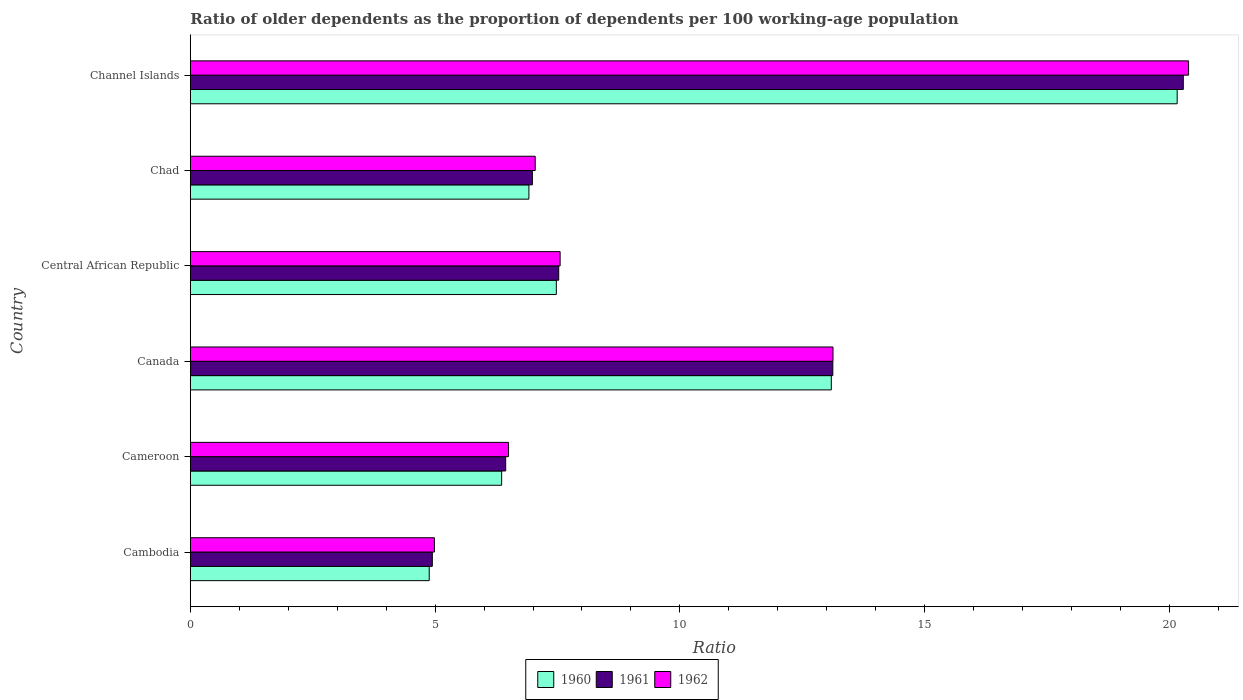Are the number of bars per tick equal to the number of legend labels?
Offer a terse response. Yes. Are the number of bars on each tick of the Y-axis equal?
Your answer should be very brief. Yes. How many bars are there on the 1st tick from the top?
Ensure brevity in your answer.  3. What is the label of the 5th group of bars from the top?
Your response must be concise. Cameroon. What is the age dependency ratio(old) in 1961 in Cameroon?
Offer a terse response. 6.44. Across all countries, what is the maximum age dependency ratio(old) in 1962?
Give a very brief answer. 20.39. Across all countries, what is the minimum age dependency ratio(old) in 1961?
Provide a short and direct response. 4.94. In which country was the age dependency ratio(old) in 1961 maximum?
Provide a short and direct response. Channel Islands. In which country was the age dependency ratio(old) in 1961 minimum?
Offer a very short reply. Cambodia. What is the total age dependency ratio(old) in 1962 in the graph?
Provide a short and direct response. 59.6. What is the difference between the age dependency ratio(old) in 1960 in Canada and that in Chad?
Offer a very short reply. 6.18. What is the difference between the age dependency ratio(old) in 1961 in Cameroon and the age dependency ratio(old) in 1962 in Channel Islands?
Your answer should be very brief. -13.95. What is the average age dependency ratio(old) in 1961 per country?
Give a very brief answer. 9.88. What is the difference between the age dependency ratio(old) in 1960 and age dependency ratio(old) in 1961 in Cambodia?
Your response must be concise. -0.06. In how many countries, is the age dependency ratio(old) in 1961 greater than 16 ?
Your answer should be compact. 1. What is the ratio of the age dependency ratio(old) in 1962 in Cameroon to that in Canada?
Give a very brief answer. 0.5. Is the age dependency ratio(old) in 1961 in Cameroon less than that in Channel Islands?
Provide a succinct answer. Yes. What is the difference between the highest and the second highest age dependency ratio(old) in 1962?
Give a very brief answer. 7.26. What is the difference between the highest and the lowest age dependency ratio(old) in 1960?
Your answer should be compact. 15.28. In how many countries, is the age dependency ratio(old) in 1961 greater than the average age dependency ratio(old) in 1961 taken over all countries?
Your answer should be very brief. 2. Is the sum of the age dependency ratio(old) in 1961 in Chad and Channel Islands greater than the maximum age dependency ratio(old) in 1960 across all countries?
Offer a terse response. Yes. What does the 2nd bar from the top in Chad represents?
Offer a terse response. 1961. Is it the case that in every country, the sum of the age dependency ratio(old) in 1961 and age dependency ratio(old) in 1962 is greater than the age dependency ratio(old) in 1960?
Ensure brevity in your answer.  Yes. Are all the bars in the graph horizontal?
Make the answer very short. Yes. Does the graph contain grids?
Ensure brevity in your answer.  No. Where does the legend appear in the graph?
Offer a very short reply. Bottom center. How many legend labels are there?
Offer a terse response. 3. How are the legend labels stacked?
Provide a short and direct response. Horizontal. What is the title of the graph?
Keep it short and to the point. Ratio of older dependents as the proportion of dependents per 100 working-age population. Does "1999" appear as one of the legend labels in the graph?
Offer a terse response. No. What is the label or title of the X-axis?
Offer a terse response. Ratio. What is the label or title of the Y-axis?
Ensure brevity in your answer.  Country. What is the Ratio of 1960 in Cambodia?
Your answer should be compact. 4.88. What is the Ratio of 1961 in Cambodia?
Keep it short and to the point. 4.94. What is the Ratio in 1962 in Cambodia?
Offer a terse response. 4.99. What is the Ratio of 1960 in Cameroon?
Your response must be concise. 6.36. What is the Ratio of 1961 in Cameroon?
Offer a terse response. 6.44. What is the Ratio of 1962 in Cameroon?
Give a very brief answer. 6.5. What is the Ratio of 1960 in Canada?
Offer a terse response. 13.09. What is the Ratio of 1961 in Canada?
Give a very brief answer. 13.12. What is the Ratio in 1962 in Canada?
Offer a very short reply. 13.13. What is the Ratio of 1960 in Central African Republic?
Keep it short and to the point. 7.48. What is the Ratio of 1961 in Central African Republic?
Provide a short and direct response. 7.53. What is the Ratio of 1962 in Central African Republic?
Make the answer very short. 7.55. What is the Ratio in 1960 in Chad?
Offer a terse response. 6.92. What is the Ratio of 1961 in Chad?
Provide a succinct answer. 6.99. What is the Ratio in 1962 in Chad?
Offer a very short reply. 7.05. What is the Ratio of 1960 in Channel Islands?
Your answer should be very brief. 20.16. What is the Ratio in 1961 in Channel Islands?
Your answer should be compact. 20.28. What is the Ratio of 1962 in Channel Islands?
Provide a succinct answer. 20.39. Across all countries, what is the maximum Ratio in 1960?
Your response must be concise. 20.16. Across all countries, what is the maximum Ratio in 1961?
Give a very brief answer. 20.28. Across all countries, what is the maximum Ratio of 1962?
Your answer should be very brief. 20.39. Across all countries, what is the minimum Ratio in 1960?
Keep it short and to the point. 4.88. Across all countries, what is the minimum Ratio of 1961?
Your response must be concise. 4.94. Across all countries, what is the minimum Ratio in 1962?
Your answer should be compact. 4.99. What is the total Ratio of 1960 in the graph?
Your answer should be compact. 58.88. What is the total Ratio of 1961 in the graph?
Ensure brevity in your answer.  59.3. What is the total Ratio of 1962 in the graph?
Provide a short and direct response. 59.6. What is the difference between the Ratio of 1960 in Cambodia and that in Cameroon?
Your answer should be very brief. -1.48. What is the difference between the Ratio in 1961 in Cambodia and that in Cameroon?
Offer a terse response. -1.5. What is the difference between the Ratio in 1962 in Cambodia and that in Cameroon?
Ensure brevity in your answer.  -1.51. What is the difference between the Ratio of 1960 in Cambodia and that in Canada?
Ensure brevity in your answer.  -8.21. What is the difference between the Ratio in 1961 in Cambodia and that in Canada?
Make the answer very short. -8.18. What is the difference between the Ratio of 1962 in Cambodia and that in Canada?
Ensure brevity in your answer.  -8.14. What is the difference between the Ratio in 1960 in Cambodia and that in Central African Republic?
Your answer should be very brief. -2.6. What is the difference between the Ratio in 1961 in Cambodia and that in Central African Republic?
Your response must be concise. -2.58. What is the difference between the Ratio in 1962 in Cambodia and that in Central African Republic?
Provide a short and direct response. -2.57. What is the difference between the Ratio of 1960 in Cambodia and that in Chad?
Your response must be concise. -2.04. What is the difference between the Ratio of 1961 in Cambodia and that in Chad?
Give a very brief answer. -2.04. What is the difference between the Ratio of 1962 in Cambodia and that in Chad?
Give a very brief answer. -2.06. What is the difference between the Ratio of 1960 in Cambodia and that in Channel Islands?
Offer a terse response. -15.28. What is the difference between the Ratio in 1961 in Cambodia and that in Channel Islands?
Your response must be concise. -15.34. What is the difference between the Ratio of 1962 in Cambodia and that in Channel Islands?
Your answer should be very brief. -15.4. What is the difference between the Ratio in 1960 in Cameroon and that in Canada?
Keep it short and to the point. -6.73. What is the difference between the Ratio in 1961 in Cameroon and that in Canada?
Your answer should be compact. -6.68. What is the difference between the Ratio of 1962 in Cameroon and that in Canada?
Ensure brevity in your answer.  -6.63. What is the difference between the Ratio of 1960 in Cameroon and that in Central African Republic?
Give a very brief answer. -1.12. What is the difference between the Ratio in 1961 in Cameroon and that in Central African Republic?
Your response must be concise. -1.08. What is the difference between the Ratio of 1962 in Cameroon and that in Central African Republic?
Your answer should be very brief. -1.05. What is the difference between the Ratio in 1960 in Cameroon and that in Chad?
Give a very brief answer. -0.56. What is the difference between the Ratio in 1961 in Cameroon and that in Chad?
Provide a short and direct response. -0.55. What is the difference between the Ratio of 1962 in Cameroon and that in Chad?
Provide a short and direct response. -0.54. What is the difference between the Ratio in 1960 in Cameroon and that in Channel Islands?
Your response must be concise. -13.8. What is the difference between the Ratio of 1961 in Cameroon and that in Channel Islands?
Ensure brevity in your answer.  -13.84. What is the difference between the Ratio of 1962 in Cameroon and that in Channel Islands?
Your answer should be compact. -13.89. What is the difference between the Ratio in 1960 in Canada and that in Central African Republic?
Your answer should be very brief. 5.62. What is the difference between the Ratio in 1961 in Canada and that in Central African Republic?
Offer a terse response. 5.6. What is the difference between the Ratio of 1962 in Canada and that in Central African Republic?
Make the answer very short. 5.57. What is the difference between the Ratio in 1960 in Canada and that in Chad?
Ensure brevity in your answer.  6.18. What is the difference between the Ratio of 1961 in Canada and that in Chad?
Your response must be concise. 6.14. What is the difference between the Ratio of 1962 in Canada and that in Chad?
Provide a short and direct response. 6.08. What is the difference between the Ratio of 1960 in Canada and that in Channel Islands?
Provide a succinct answer. -7.06. What is the difference between the Ratio in 1961 in Canada and that in Channel Islands?
Keep it short and to the point. -7.16. What is the difference between the Ratio in 1962 in Canada and that in Channel Islands?
Ensure brevity in your answer.  -7.26. What is the difference between the Ratio in 1960 in Central African Republic and that in Chad?
Your response must be concise. 0.56. What is the difference between the Ratio of 1961 in Central African Republic and that in Chad?
Offer a terse response. 0.54. What is the difference between the Ratio of 1962 in Central African Republic and that in Chad?
Provide a short and direct response. 0.51. What is the difference between the Ratio of 1960 in Central African Republic and that in Channel Islands?
Provide a succinct answer. -12.68. What is the difference between the Ratio of 1961 in Central African Republic and that in Channel Islands?
Offer a very short reply. -12.76. What is the difference between the Ratio in 1962 in Central African Republic and that in Channel Islands?
Keep it short and to the point. -12.84. What is the difference between the Ratio of 1960 in Chad and that in Channel Islands?
Keep it short and to the point. -13.24. What is the difference between the Ratio in 1961 in Chad and that in Channel Islands?
Your answer should be compact. -13.3. What is the difference between the Ratio in 1962 in Chad and that in Channel Islands?
Offer a very short reply. -13.35. What is the difference between the Ratio in 1960 in Cambodia and the Ratio in 1961 in Cameroon?
Your answer should be compact. -1.56. What is the difference between the Ratio of 1960 in Cambodia and the Ratio of 1962 in Cameroon?
Your answer should be compact. -1.62. What is the difference between the Ratio in 1961 in Cambodia and the Ratio in 1962 in Cameroon?
Your answer should be very brief. -1.56. What is the difference between the Ratio of 1960 in Cambodia and the Ratio of 1961 in Canada?
Your response must be concise. -8.24. What is the difference between the Ratio in 1960 in Cambodia and the Ratio in 1962 in Canada?
Your response must be concise. -8.25. What is the difference between the Ratio in 1961 in Cambodia and the Ratio in 1962 in Canada?
Make the answer very short. -8.18. What is the difference between the Ratio of 1960 in Cambodia and the Ratio of 1961 in Central African Republic?
Keep it short and to the point. -2.65. What is the difference between the Ratio of 1960 in Cambodia and the Ratio of 1962 in Central African Republic?
Provide a short and direct response. -2.67. What is the difference between the Ratio in 1961 in Cambodia and the Ratio in 1962 in Central African Republic?
Provide a succinct answer. -2.61. What is the difference between the Ratio in 1960 in Cambodia and the Ratio in 1961 in Chad?
Provide a succinct answer. -2.11. What is the difference between the Ratio of 1960 in Cambodia and the Ratio of 1962 in Chad?
Provide a short and direct response. -2.17. What is the difference between the Ratio of 1961 in Cambodia and the Ratio of 1962 in Chad?
Your response must be concise. -2.1. What is the difference between the Ratio in 1960 in Cambodia and the Ratio in 1961 in Channel Islands?
Give a very brief answer. -15.4. What is the difference between the Ratio of 1960 in Cambodia and the Ratio of 1962 in Channel Islands?
Make the answer very short. -15.51. What is the difference between the Ratio of 1961 in Cambodia and the Ratio of 1962 in Channel Islands?
Your response must be concise. -15.45. What is the difference between the Ratio in 1960 in Cameroon and the Ratio in 1961 in Canada?
Your answer should be very brief. -6.76. What is the difference between the Ratio in 1960 in Cameroon and the Ratio in 1962 in Canada?
Your answer should be very brief. -6.77. What is the difference between the Ratio of 1961 in Cameroon and the Ratio of 1962 in Canada?
Ensure brevity in your answer.  -6.69. What is the difference between the Ratio of 1960 in Cameroon and the Ratio of 1961 in Central African Republic?
Your answer should be very brief. -1.17. What is the difference between the Ratio of 1960 in Cameroon and the Ratio of 1962 in Central African Republic?
Keep it short and to the point. -1.19. What is the difference between the Ratio of 1961 in Cameroon and the Ratio of 1962 in Central African Republic?
Provide a short and direct response. -1.11. What is the difference between the Ratio in 1960 in Cameroon and the Ratio in 1961 in Chad?
Offer a very short reply. -0.63. What is the difference between the Ratio of 1960 in Cameroon and the Ratio of 1962 in Chad?
Your response must be concise. -0.69. What is the difference between the Ratio in 1961 in Cameroon and the Ratio in 1962 in Chad?
Your answer should be very brief. -0.6. What is the difference between the Ratio in 1960 in Cameroon and the Ratio in 1961 in Channel Islands?
Provide a short and direct response. -13.92. What is the difference between the Ratio in 1960 in Cameroon and the Ratio in 1962 in Channel Islands?
Your answer should be very brief. -14.03. What is the difference between the Ratio in 1961 in Cameroon and the Ratio in 1962 in Channel Islands?
Ensure brevity in your answer.  -13.95. What is the difference between the Ratio of 1960 in Canada and the Ratio of 1961 in Central African Republic?
Provide a short and direct response. 5.57. What is the difference between the Ratio in 1960 in Canada and the Ratio in 1962 in Central African Republic?
Your answer should be compact. 5.54. What is the difference between the Ratio of 1961 in Canada and the Ratio of 1962 in Central African Republic?
Your response must be concise. 5.57. What is the difference between the Ratio in 1960 in Canada and the Ratio in 1961 in Chad?
Make the answer very short. 6.11. What is the difference between the Ratio of 1960 in Canada and the Ratio of 1962 in Chad?
Offer a very short reply. 6.05. What is the difference between the Ratio in 1961 in Canada and the Ratio in 1962 in Chad?
Give a very brief answer. 6.08. What is the difference between the Ratio in 1960 in Canada and the Ratio in 1961 in Channel Islands?
Give a very brief answer. -7.19. What is the difference between the Ratio of 1960 in Canada and the Ratio of 1962 in Channel Islands?
Ensure brevity in your answer.  -7.3. What is the difference between the Ratio of 1961 in Canada and the Ratio of 1962 in Channel Islands?
Give a very brief answer. -7.27. What is the difference between the Ratio of 1960 in Central African Republic and the Ratio of 1961 in Chad?
Provide a succinct answer. 0.49. What is the difference between the Ratio of 1960 in Central African Republic and the Ratio of 1962 in Chad?
Your answer should be compact. 0.43. What is the difference between the Ratio in 1961 in Central African Republic and the Ratio in 1962 in Chad?
Offer a terse response. 0.48. What is the difference between the Ratio of 1960 in Central African Republic and the Ratio of 1961 in Channel Islands?
Your answer should be compact. -12.81. What is the difference between the Ratio of 1960 in Central African Republic and the Ratio of 1962 in Channel Islands?
Make the answer very short. -12.91. What is the difference between the Ratio in 1961 in Central African Republic and the Ratio in 1962 in Channel Islands?
Keep it short and to the point. -12.87. What is the difference between the Ratio of 1960 in Chad and the Ratio of 1961 in Channel Islands?
Provide a succinct answer. -13.37. What is the difference between the Ratio of 1960 in Chad and the Ratio of 1962 in Channel Islands?
Provide a succinct answer. -13.47. What is the difference between the Ratio of 1961 in Chad and the Ratio of 1962 in Channel Islands?
Provide a succinct answer. -13.4. What is the average Ratio in 1960 per country?
Your answer should be compact. 9.81. What is the average Ratio of 1961 per country?
Your answer should be compact. 9.88. What is the average Ratio of 1962 per country?
Your answer should be compact. 9.93. What is the difference between the Ratio in 1960 and Ratio in 1961 in Cambodia?
Your response must be concise. -0.06. What is the difference between the Ratio in 1960 and Ratio in 1962 in Cambodia?
Offer a terse response. -0.11. What is the difference between the Ratio of 1961 and Ratio of 1962 in Cambodia?
Ensure brevity in your answer.  -0.04. What is the difference between the Ratio in 1960 and Ratio in 1961 in Cameroon?
Your answer should be very brief. -0.08. What is the difference between the Ratio in 1960 and Ratio in 1962 in Cameroon?
Provide a short and direct response. -0.14. What is the difference between the Ratio in 1961 and Ratio in 1962 in Cameroon?
Your answer should be compact. -0.06. What is the difference between the Ratio of 1960 and Ratio of 1961 in Canada?
Provide a short and direct response. -0.03. What is the difference between the Ratio in 1960 and Ratio in 1962 in Canada?
Provide a succinct answer. -0.03. What is the difference between the Ratio in 1961 and Ratio in 1962 in Canada?
Your response must be concise. -0. What is the difference between the Ratio of 1960 and Ratio of 1961 in Central African Republic?
Ensure brevity in your answer.  -0.05. What is the difference between the Ratio of 1960 and Ratio of 1962 in Central African Republic?
Offer a very short reply. -0.08. What is the difference between the Ratio of 1961 and Ratio of 1962 in Central African Republic?
Keep it short and to the point. -0.03. What is the difference between the Ratio of 1960 and Ratio of 1961 in Chad?
Your answer should be very brief. -0.07. What is the difference between the Ratio of 1960 and Ratio of 1962 in Chad?
Your answer should be compact. -0.13. What is the difference between the Ratio in 1961 and Ratio in 1962 in Chad?
Make the answer very short. -0.06. What is the difference between the Ratio in 1960 and Ratio in 1961 in Channel Islands?
Provide a succinct answer. -0.12. What is the difference between the Ratio in 1960 and Ratio in 1962 in Channel Islands?
Provide a short and direct response. -0.23. What is the difference between the Ratio of 1961 and Ratio of 1962 in Channel Islands?
Keep it short and to the point. -0.11. What is the ratio of the Ratio of 1960 in Cambodia to that in Cameroon?
Your answer should be compact. 0.77. What is the ratio of the Ratio in 1961 in Cambodia to that in Cameroon?
Offer a very short reply. 0.77. What is the ratio of the Ratio in 1962 in Cambodia to that in Cameroon?
Your response must be concise. 0.77. What is the ratio of the Ratio of 1960 in Cambodia to that in Canada?
Your answer should be very brief. 0.37. What is the ratio of the Ratio in 1961 in Cambodia to that in Canada?
Your answer should be compact. 0.38. What is the ratio of the Ratio of 1962 in Cambodia to that in Canada?
Your answer should be very brief. 0.38. What is the ratio of the Ratio in 1960 in Cambodia to that in Central African Republic?
Offer a very short reply. 0.65. What is the ratio of the Ratio in 1961 in Cambodia to that in Central African Republic?
Your answer should be compact. 0.66. What is the ratio of the Ratio in 1962 in Cambodia to that in Central African Republic?
Keep it short and to the point. 0.66. What is the ratio of the Ratio of 1960 in Cambodia to that in Chad?
Your answer should be compact. 0.71. What is the ratio of the Ratio in 1961 in Cambodia to that in Chad?
Give a very brief answer. 0.71. What is the ratio of the Ratio of 1962 in Cambodia to that in Chad?
Give a very brief answer. 0.71. What is the ratio of the Ratio of 1960 in Cambodia to that in Channel Islands?
Ensure brevity in your answer.  0.24. What is the ratio of the Ratio in 1961 in Cambodia to that in Channel Islands?
Offer a very short reply. 0.24. What is the ratio of the Ratio of 1962 in Cambodia to that in Channel Islands?
Keep it short and to the point. 0.24. What is the ratio of the Ratio of 1960 in Cameroon to that in Canada?
Your answer should be compact. 0.49. What is the ratio of the Ratio of 1961 in Cameroon to that in Canada?
Your answer should be very brief. 0.49. What is the ratio of the Ratio in 1962 in Cameroon to that in Canada?
Your answer should be compact. 0.5. What is the ratio of the Ratio of 1960 in Cameroon to that in Central African Republic?
Your answer should be very brief. 0.85. What is the ratio of the Ratio in 1961 in Cameroon to that in Central African Republic?
Give a very brief answer. 0.86. What is the ratio of the Ratio of 1962 in Cameroon to that in Central African Republic?
Provide a short and direct response. 0.86. What is the ratio of the Ratio of 1960 in Cameroon to that in Chad?
Offer a terse response. 0.92. What is the ratio of the Ratio in 1961 in Cameroon to that in Chad?
Keep it short and to the point. 0.92. What is the ratio of the Ratio in 1962 in Cameroon to that in Chad?
Provide a short and direct response. 0.92. What is the ratio of the Ratio in 1960 in Cameroon to that in Channel Islands?
Keep it short and to the point. 0.32. What is the ratio of the Ratio in 1961 in Cameroon to that in Channel Islands?
Ensure brevity in your answer.  0.32. What is the ratio of the Ratio of 1962 in Cameroon to that in Channel Islands?
Give a very brief answer. 0.32. What is the ratio of the Ratio in 1960 in Canada to that in Central African Republic?
Your response must be concise. 1.75. What is the ratio of the Ratio in 1961 in Canada to that in Central African Republic?
Offer a terse response. 1.74. What is the ratio of the Ratio of 1962 in Canada to that in Central African Republic?
Make the answer very short. 1.74. What is the ratio of the Ratio of 1960 in Canada to that in Chad?
Give a very brief answer. 1.89. What is the ratio of the Ratio in 1961 in Canada to that in Chad?
Your response must be concise. 1.88. What is the ratio of the Ratio in 1962 in Canada to that in Chad?
Ensure brevity in your answer.  1.86. What is the ratio of the Ratio of 1960 in Canada to that in Channel Islands?
Provide a short and direct response. 0.65. What is the ratio of the Ratio of 1961 in Canada to that in Channel Islands?
Give a very brief answer. 0.65. What is the ratio of the Ratio in 1962 in Canada to that in Channel Islands?
Make the answer very short. 0.64. What is the ratio of the Ratio in 1960 in Central African Republic to that in Chad?
Keep it short and to the point. 1.08. What is the ratio of the Ratio in 1961 in Central African Republic to that in Chad?
Provide a succinct answer. 1.08. What is the ratio of the Ratio in 1962 in Central African Republic to that in Chad?
Make the answer very short. 1.07. What is the ratio of the Ratio in 1960 in Central African Republic to that in Channel Islands?
Your answer should be very brief. 0.37. What is the ratio of the Ratio of 1961 in Central African Republic to that in Channel Islands?
Keep it short and to the point. 0.37. What is the ratio of the Ratio of 1962 in Central African Republic to that in Channel Islands?
Give a very brief answer. 0.37. What is the ratio of the Ratio in 1960 in Chad to that in Channel Islands?
Provide a succinct answer. 0.34. What is the ratio of the Ratio of 1961 in Chad to that in Channel Islands?
Your response must be concise. 0.34. What is the ratio of the Ratio of 1962 in Chad to that in Channel Islands?
Give a very brief answer. 0.35. What is the difference between the highest and the second highest Ratio in 1960?
Offer a very short reply. 7.06. What is the difference between the highest and the second highest Ratio in 1961?
Offer a very short reply. 7.16. What is the difference between the highest and the second highest Ratio of 1962?
Make the answer very short. 7.26. What is the difference between the highest and the lowest Ratio in 1960?
Provide a succinct answer. 15.28. What is the difference between the highest and the lowest Ratio of 1961?
Give a very brief answer. 15.34. What is the difference between the highest and the lowest Ratio of 1962?
Offer a very short reply. 15.4. 